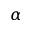<formula> <loc_0><loc_0><loc_500><loc_500>\alpha</formula> 